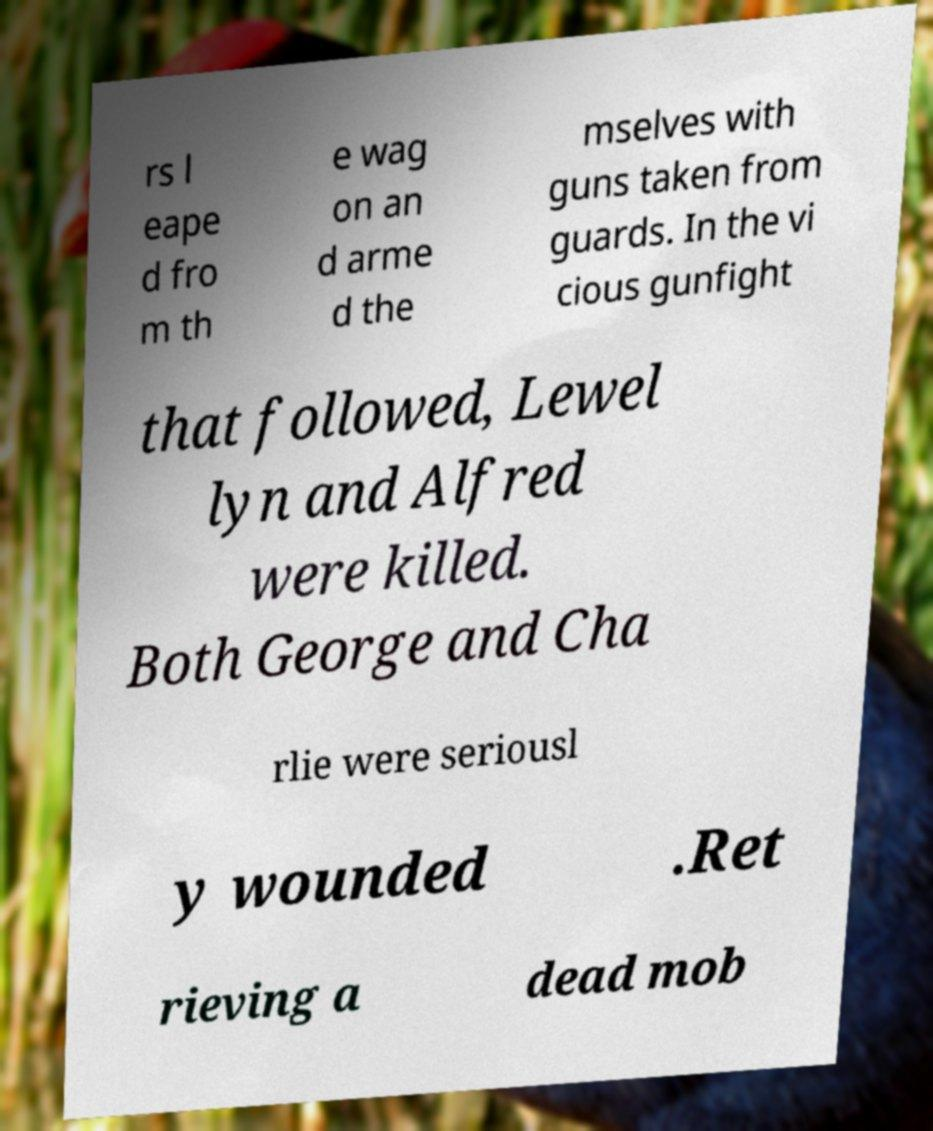Please identify and transcribe the text found in this image. rs l eape d fro m th e wag on an d arme d the mselves with guns taken from guards. In the vi cious gunfight that followed, Lewel lyn and Alfred were killed. Both George and Cha rlie were seriousl y wounded .Ret rieving a dead mob 